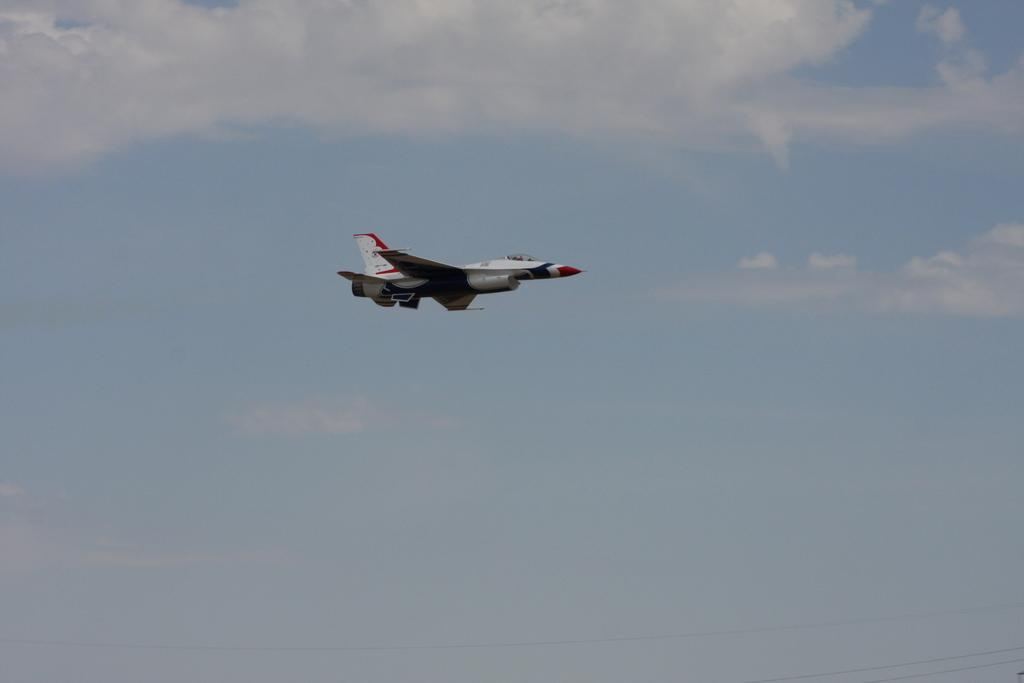What is the main subject of the image? The main subject of the image is an aeroplane. What is the aeroplane doing in the image? The aeroplane is flying in the air. What can be seen in the background of the image? The sky is visible in the background of the image. What else is present in the sky? Clouds are present in the sky. Where are the cattle located in the image? There are no cattle present in the image; it features an aeroplane flying in the sky. 